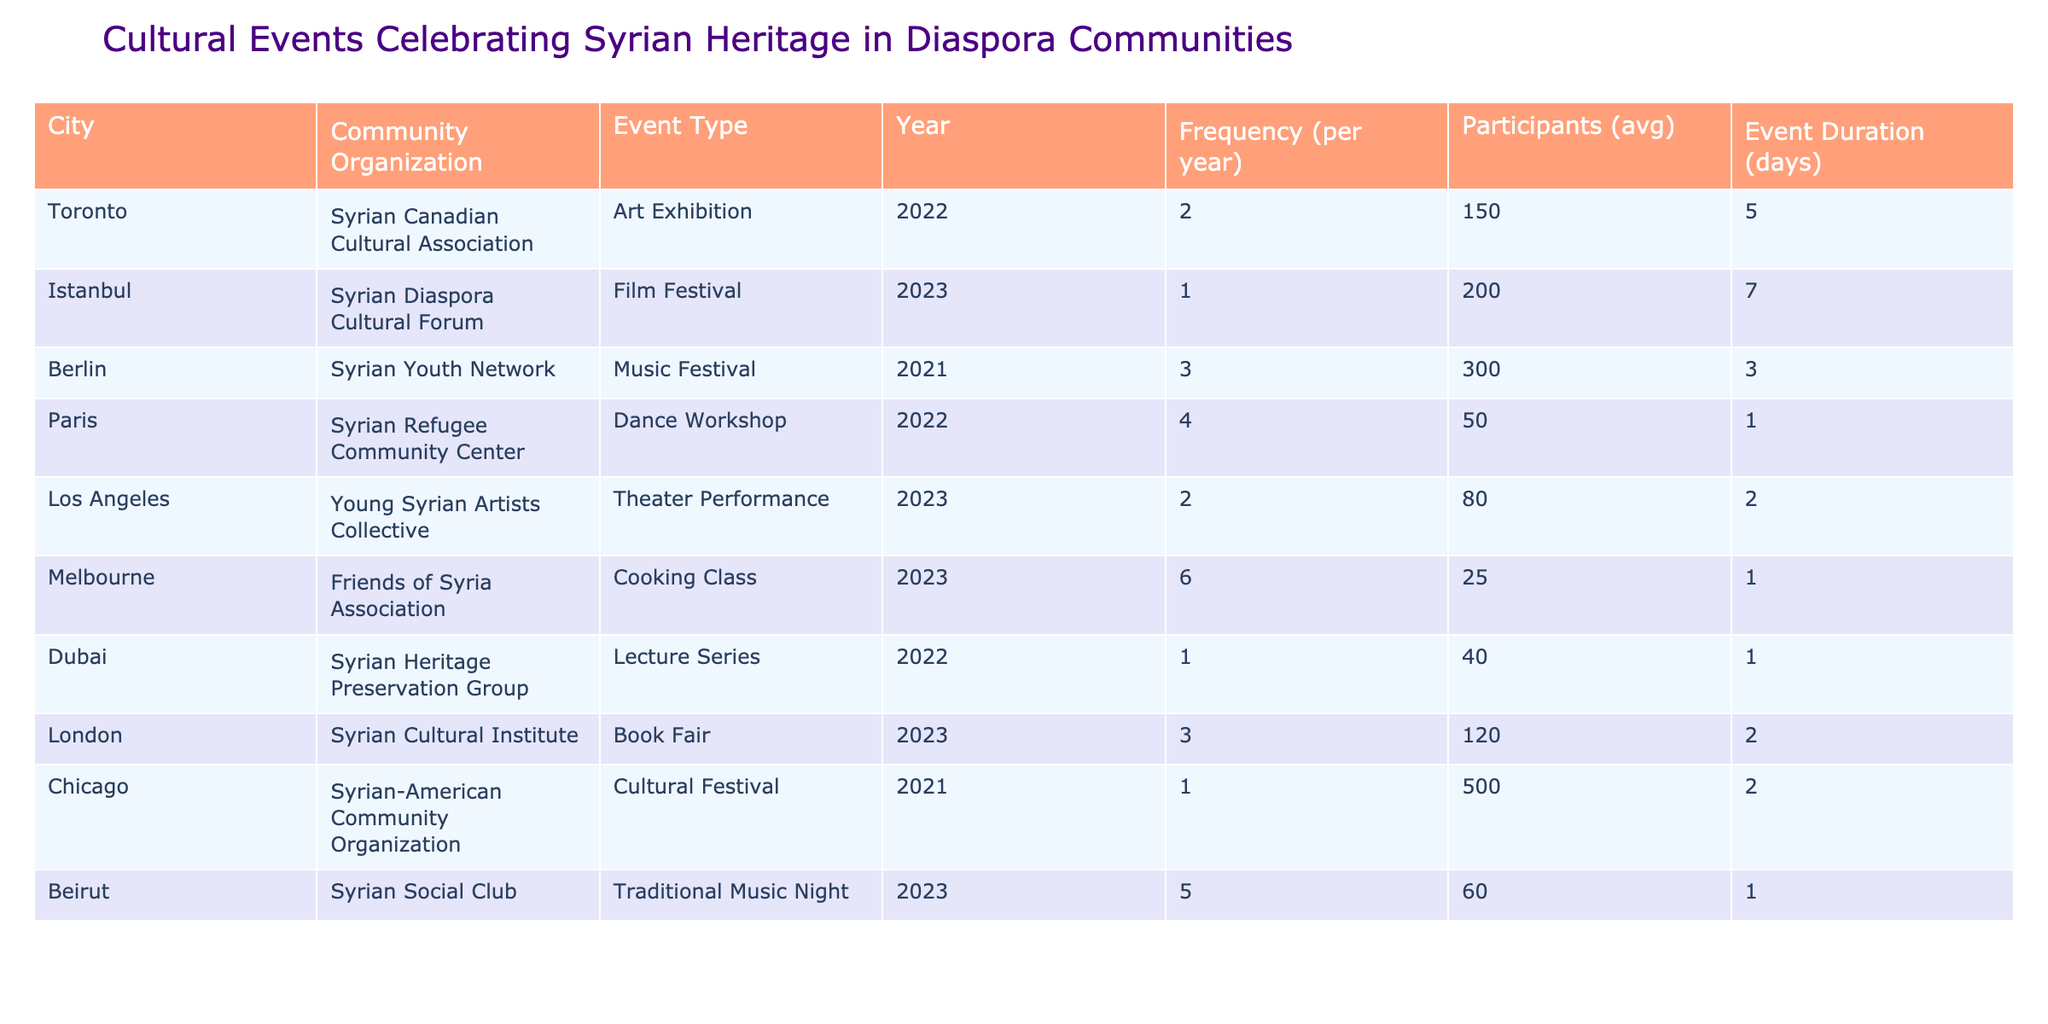What city hosts the Cooking Class event celebrating Syrian heritage? The Cooking Class is organized by the Friends of Syria Association in Melbourne.
Answer: Melbourne Which event had the highest average number of participants? The Cultural Festival organized by the Syrian-American Community Organization in Chicago had the highest average number of participants at 500.
Answer: 500 How many events were held in 2023? The events held in 2023 include a Film Festival, a Theater Performance, a Book Fair, and a Traditional Music Night, totaling four events.
Answer: 4 What is the average frequency of cultural events across all listed communities? To find the average, sum the frequencies: (2 + 1 + 3 + 4 + 2 + 6 + 1 + 3 + 1 + 5) = 28. Divide by the total number of events (10), which gives an average frequency of 2.8.
Answer: 2.8 Which community organization organized an event with a duration of more than 5 days? The Film Festival organized by the Syrian Diaspora Cultural Forum in Istanbul has a duration of 7 days, which is more than 5 days.
Answer: Yes Is there any event in Dubai? Yes, Dubai has a Lecture Series organized by the Syrian Heritage Preservation Group.
Answer: Yes What is the difference in average participants between the Cooking Class and the Film Festival? The average participants for the Cooking Class is 25, and for the Film Festival, it is 200. The difference is 200 - 25 = 175.
Answer: 175 Which city had two events in the same year? The table shows that Toronto and Berlin both organized two events in different years, but no city had two events in the same year.
Answer: No How many days did the Traditional Music Night in Beirut last? The Traditional Music Night in Beirut lasted for 1 day as indicated in the table.
Answer: 1 What is the sum of the frequencies for events held in 2022? The frequencies for events in 2022 are 2 (Toronto) + 4 (Paris) + 1 (Dubai) = 7.
Answer: 7 